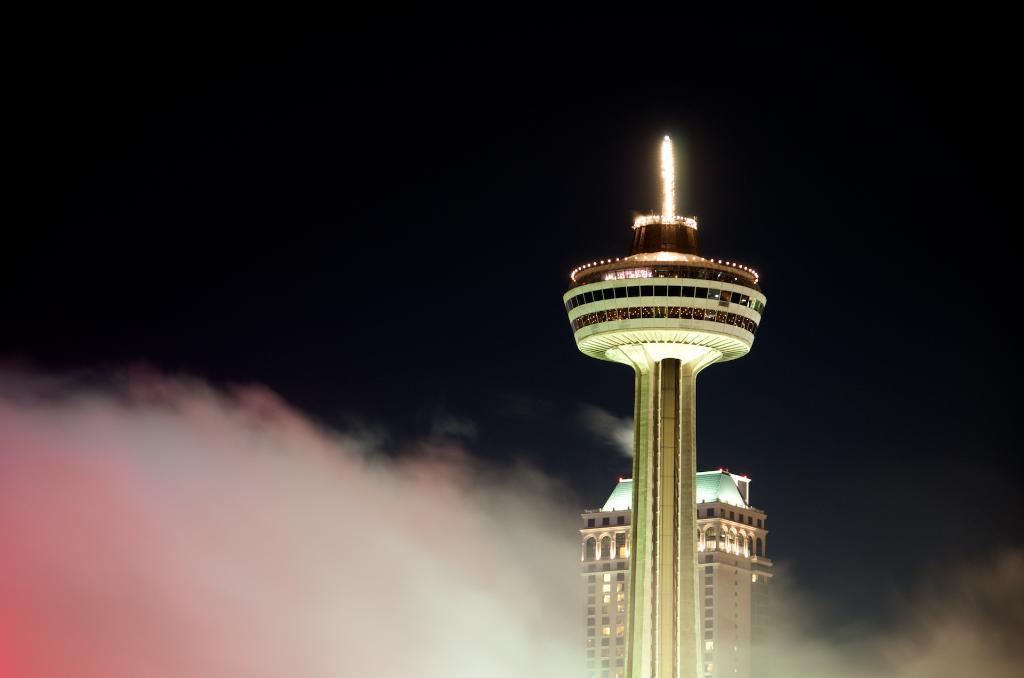What structures are present in the image? There are towers in the image. What atmospheric condition can be observed in the background of the image? There is fog visible in the background of the image. What type of card is being used to approve the construction of the towers in the image? There is no card or approval process depicted in the image; it only shows the towers and the fog in the background. 